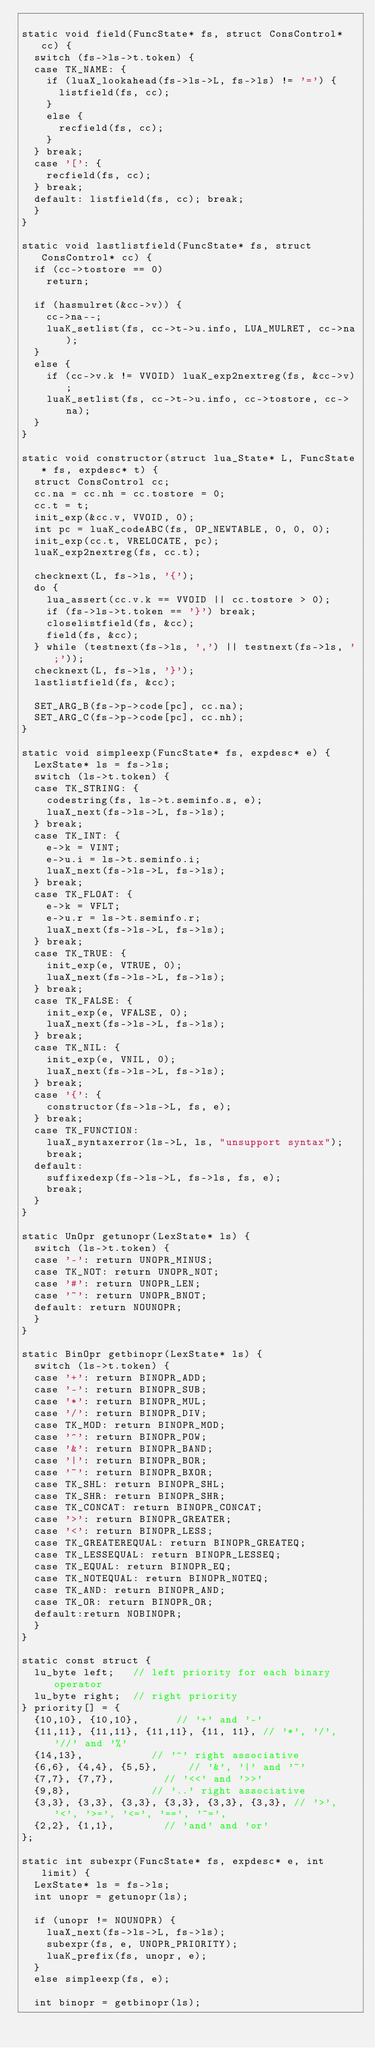<code> <loc_0><loc_0><loc_500><loc_500><_C_>
static void field(FuncState* fs, struct ConsControl* cc) {
	switch (fs->ls->t.token) {
	case TK_NAME: {
		if (luaX_lookahead(fs->ls->L, fs->ls) != '=') {
			listfield(fs, cc);
		}
		else {
			recfield(fs, cc);
		}
	} break;
	case '[': {
		recfield(fs, cc);
	} break;
	default: listfield(fs, cc); break;
	}
}

static void lastlistfield(FuncState* fs, struct ConsControl* cc) {
	if (cc->tostore == 0) 
		return;

	if (hasmulret(&cc->v)) {
		cc->na--;
		luaK_setlist(fs, cc->t->u.info, LUA_MULRET, cc->na);
	}
	else {
		if (cc->v.k != VVOID) luaK_exp2nextreg(fs, &cc->v);
		luaK_setlist(fs, cc->t->u.info, cc->tostore, cc->na);
	}
}

static void constructor(struct lua_State* L, FuncState* fs, expdesc* t) {
	struct ConsControl cc;
	cc.na = cc.nh = cc.tostore = 0;
	cc.t = t;
	init_exp(&cc.v, VVOID, 0);
	int pc = luaK_codeABC(fs, OP_NEWTABLE, 0, 0, 0);
	init_exp(cc.t, VRELOCATE, pc);
	luaK_exp2nextreg(fs, cc.t);

	checknext(L, fs->ls, '{');
	do {
		lua_assert(cc.v.k == VVOID || cc.tostore > 0);
		if (fs->ls->t.token == '}') break;
		closelistfield(fs, &cc);
		field(fs, &cc);
	} while (testnext(fs->ls, ',') || testnext(fs->ls, ';'));
	checknext(L, fs->ls, '}');
	lastlistfield(fs, &cc);

	SET_ARG_B(fs->p->code[pc], cc.na);
	SET_ARG_C(fs->p->code[pc], cc.nh);
}

static void simpleexp(FuncState* fs, expdesc* e) {
	LexState* ls = fs->ls;
	switch (ls->t.token) {
	case TK_STRING: {
		codestring(fs, ls->t.seminfo.s, e);
		luaX_next(fs->ls->L, fs->ls);
	} break;
	case TK_INT: {
		e->k = VINT;
		e->u.i = ls->t.seminfo.i;
		luaX_next(fs->ls->L, fs->ls);
	} break;
	case TK_FLOAT: {
		e->k = VFLT;
		e->u.r = ls->t.seminfo.r;
		luaX_next(fs->ls->L, fs->ls);
	} break;
	case TK_TRUE: {
		init_exp(e, VTRUE, 0);
		luaX_next(fs->ls->L, fs->ls);
	} break;
	case TK_FALSE: {
		init_exp(e, VFALSE, 0);
		luaX_next(fs->ls->L, fs->ls);
	} break;
	case TK_NIL: {
		init_exp(e, VNIL, 0);
		luaX_next(fs->ls->L, fs->ls);
	} break;
	case '{': {
		constructor(fs->ls->L, fs, e);
	} break;
	case TK_FUNCTION:
		luaX_syntaxerror(ls->L, ls, "unsupport syntax");
		break;
	default:
		suffixedexp(fs->ls->L, fs->ls, fs, e);
		break;
	}
}

static UnOpr getunopr(LexState* ls) {
	switch (ls->t.token) {
	case '-': return UNOPR_MINUS;
	case TK_NOT: return UNOPR_NOT;
	case '#': return UNOPR_LEN;
	case '~': return UNOPR_BNOT;
	default: return NOUNOPR;
	}
}

static BinOpr getbinopr(LexState* ls) {
	switch (ls->t.token) {
	case '+': return BINOPR_ADD;
	case '-': return BINOPR_SUB;
	case '*': return BINOPR_MUL;
	case '/': return BINOPR_DIV;
	case TK_MOD: return BINOPR_MOD;
	case '^': return BINOPR_POW;
	case '&': return BINOPR_BAND;
	case '|': return BINOPR_BOR;
	case '~': return BINOPR_BXOR;
	case TK_SHL: return BINOPR_SHL;
	case TK_SHR: return BINOPR_SHR;
	case TK_CONCAT: return BINOPR_CONCAT;
	case '>': return BINOPR_GREATER;
	case '<': return BINOPR_LESS;
	case TK_GREATEREQUAL: return BINOPR_GREATEQ;
	case TK_LESSEQUAL: return BINOPR_LESSEQ;
	case TK_EQUAL: return BINOPR_EQ;
	case TK_NOTEQUAL: return BINOPR_NOTEQ;
	case TK_AND: return BINOPR_AND;
	case TK_OR: return BINOPR_OR;
	default:return NOBINOPR;
	}
}

static const struct {
	lu_byte left;   // left priority for each binary operator
	lu_byte right;  // right priority
} priority[] = {
	{10,10}, {10,10},		   // '+' and '-'
	{11,11}, {11,11}, {11,11}, {11, 11}, // '*', '/', '//' and '%'
	{14,13},				   // '^' right associative
	{6,6}, {4,4}, {5,5},	   // '&', '|' and '~'
	{7,7}, {7,7},			   // '<<' and '>>'
	{9,8},					   // '..' right associative
	{3,3}, {3,3}, {3,3}, {3,3}, {3,3}, {3,3}, // '>', '<', '>=', '<=', '==', '~=',
	{2,2}, {1,1},			   // 'and' and 'or'
};

static int subexpr(FuncState* fs, expdesc* e, int limit) {
	LexState* ls = fs->ls;
	int unopr = getunopr(ls);

	if (unopr != NOUNOPR) {
		luaX_next(fs->ls->L, fs->ls);
		subexpr(fs, e, UNOPR_PRIORITY);
		luaK_prefix(fs, unopr, e);
	}
	else simpleexp(fs, e);

	int binopr = getbinopr(ls);</code> 